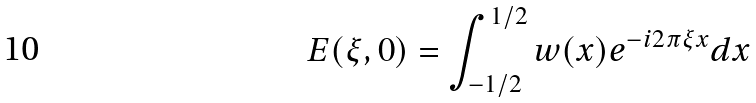<formula> <loc_0><loc_0><loc_500><loc_500>E ( \xi , 0 ) = \int _ { - 1 / 2 } ^ { 1 / 2 } { w ( x ) e ^ { - i 2 \pi \xi x } d x }</formula> 